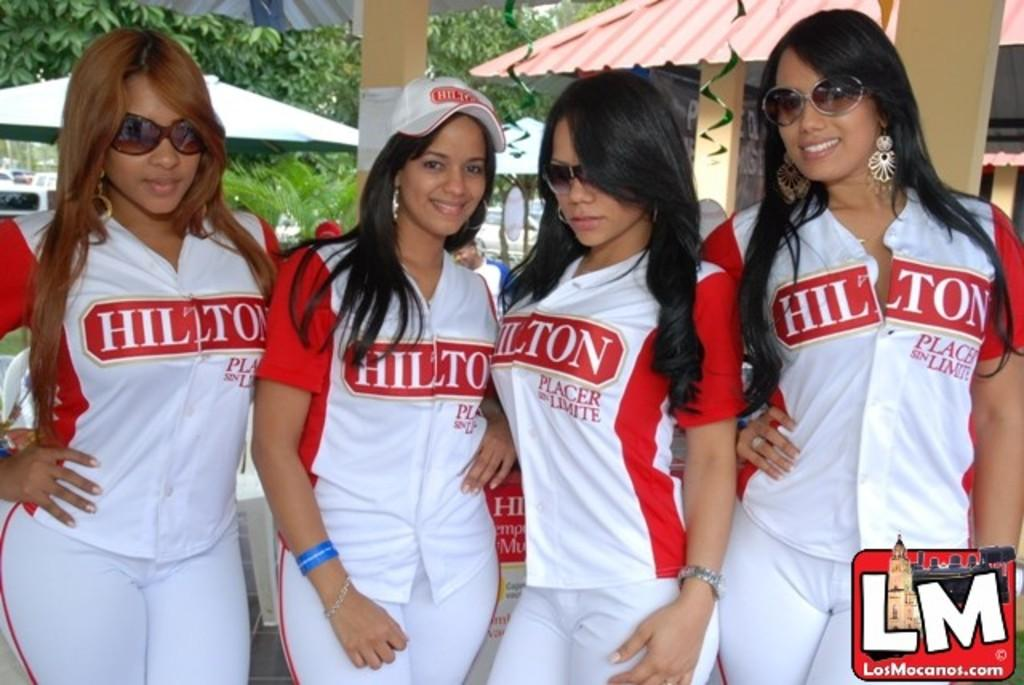Provide a one-sentence caption for the provided image. LosMacanos.com LM logo with a Hilton logo on a cap and jersey. 